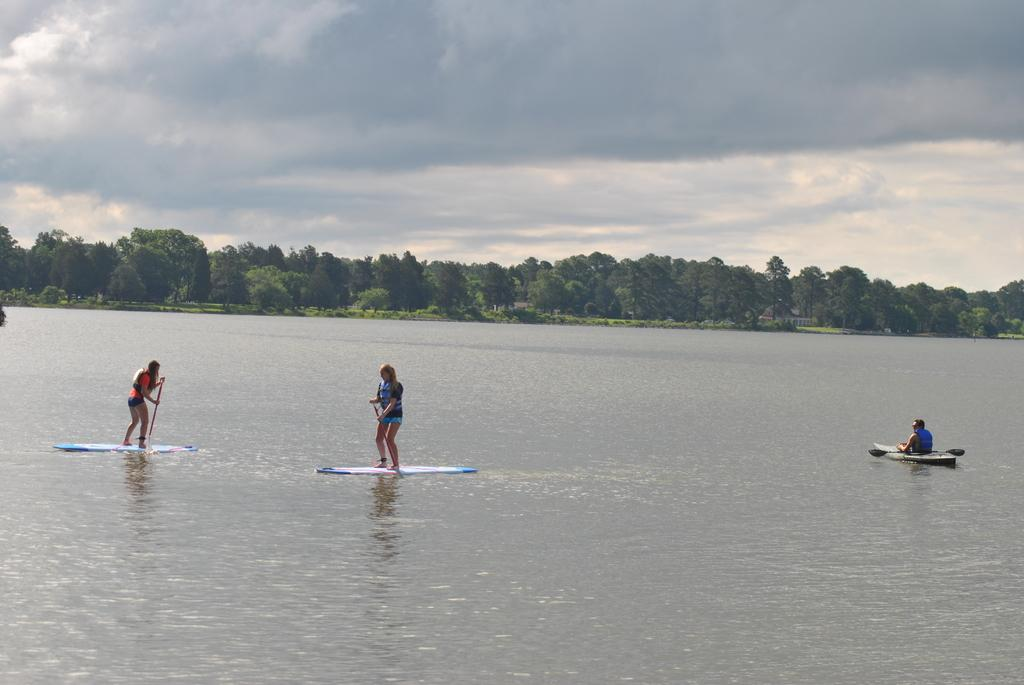What activity is the person in the image engaged in? There is a person rowing a boat in the image. Can you describe another activity taking place in the image? There are two persons standing on a surfboard in the image. What type of environment is depicted in the image? There is water visible in the image, and there are trees and the sky in the background. What can be seen in the sky in the image? Clouds are present in the sky. What type of cakes are being served in the lunchroom in the image? There is no lunchroom or cakes present in the image; it features a person rowing a boat and two persons on a surfboard in a water environment. 